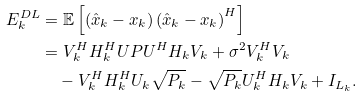Convert formula to latex. <formula><loc_0><loc_0><loc_500><loc_500>E ^ { D L } _ { k } & = \mathbb { E } \left [ \left ( \hat { x } _ { k } - x _ { k } \right ) \left ( \hat { x } _ { k } - x _ { k } \right ) ^ { H } \right ] \\ & = V _ { k } ^ { H } H _ { k } ^ { H } U P U ^ { H } H _ { k } V _ { k } + \sigma ^ { 2 } V _ { k } ^ { H } V _ { k } \\ & \quad - V _ { k } ^ { H } H _ { k } ^ { H } U _ { k } \sqrt { P _ { k } } - \sqrt { P _ { k } } U _ { k } ^ { H } H _ { k } V _ { k } + I _ { L _ { k } } .</formula> 